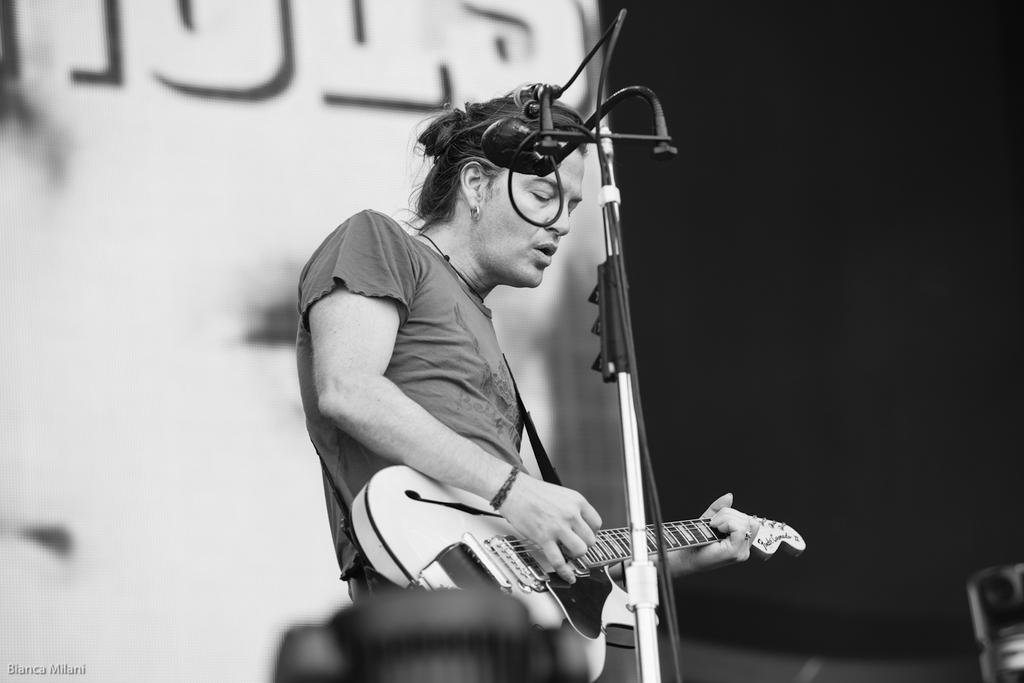Who is the main subject in the image? There is a person in the image. What is the person holding in the image? The person is holding a guitar. What is the person doing with the guitar? The person is playing the guitar. What object is in front of the person? There is a microphone in front of the person. What type of sound can be heard from the pail in the image? There is no pail present in the image, so it is not possible to determine what sound might be heard from it. 